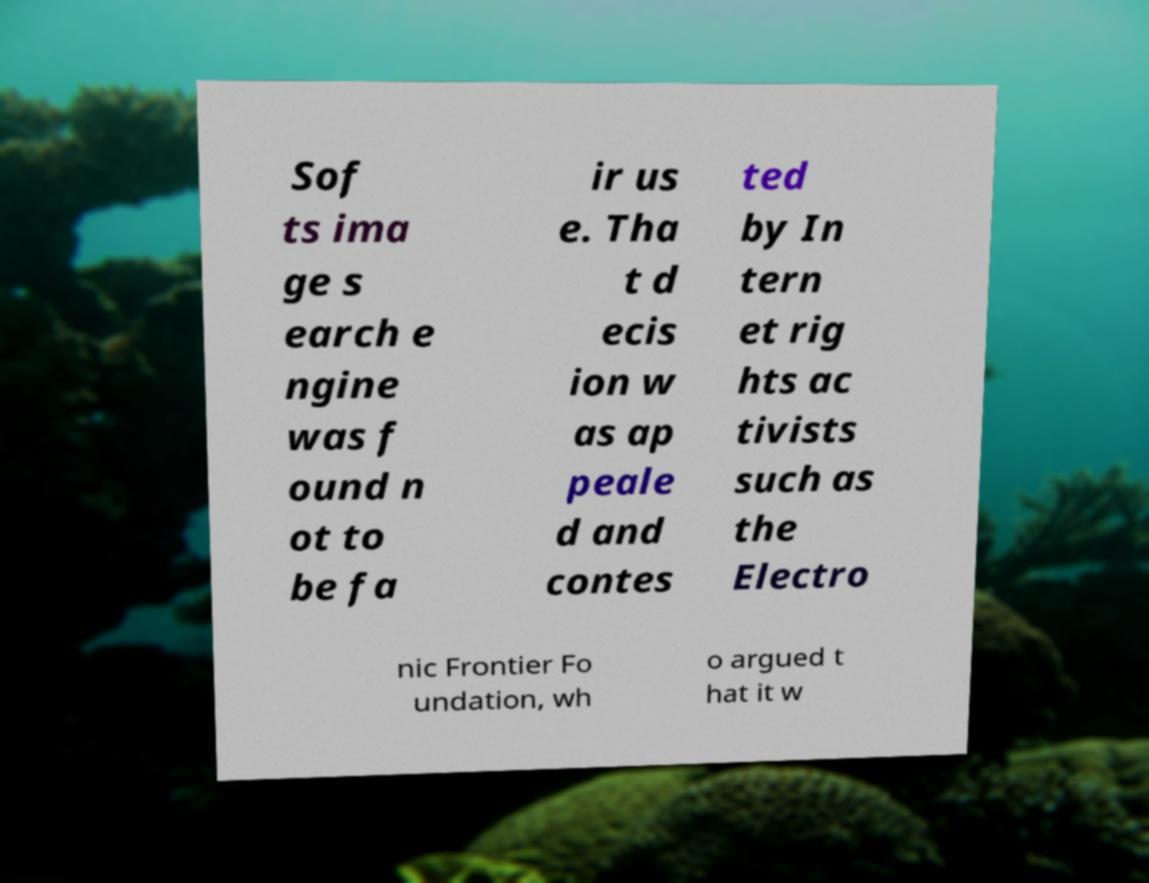What messages or text are displayed in this image? I need them in a readable, typed format. Sof ts ima ge s earch e ngine was f ound n ot to be fa ir us e. Tha t d ecis ion w as ap peale d and contes ted by In tern et rig hts ac tivists such as the Electro nic Frontier Fo undation, wh o argued t hat it w 